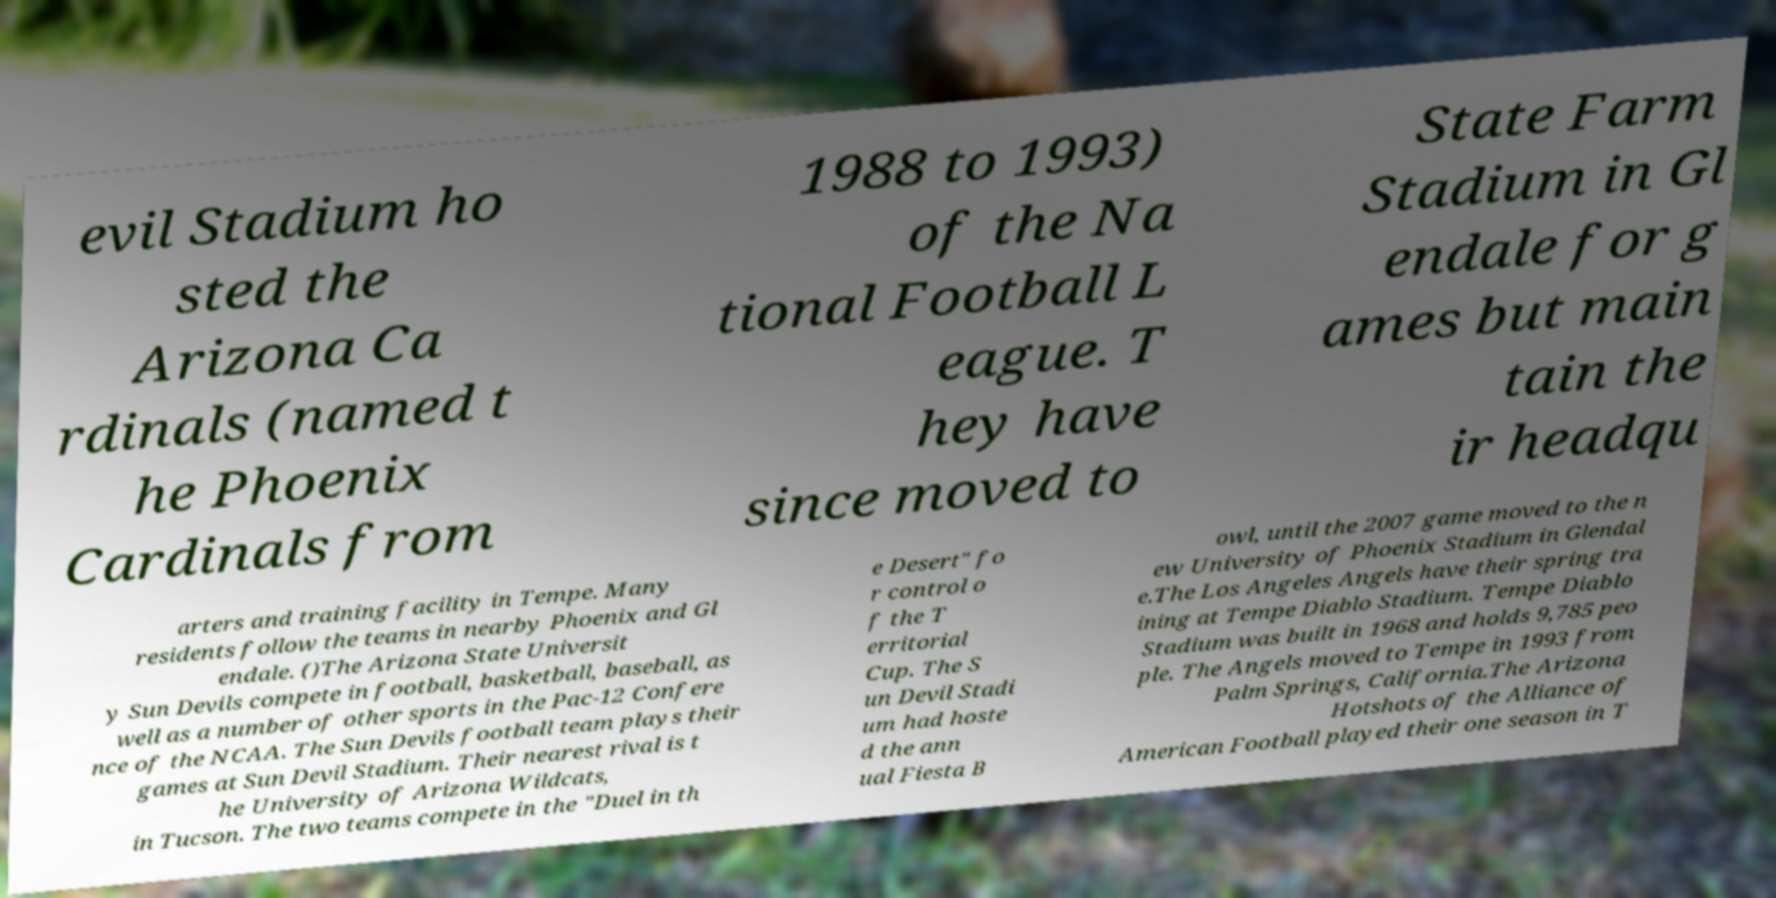For documentation purposes, I need the text within this image transcribed. Could you provide that? evil Stadium ho sted the Arizona Ca rdinals (named t he Phoenix Cardinals from 1988 to 1993) of the Na tional Football L eague. T hey have since moved to State Farm Stadium in Gl endale for g ames but main tain the ir headqu arters and training facility in Tempe. Many residents follow the teams in nearby Phoenix and Gl endale. ()The Arizona State Universit y Sun Devils compete in football, basketball, baseball, as well as a number of other sports in the Pac-12 Confere nce of the NCAA. The Sun Devils football team plays their games at Sun Devil Stadium. Their nearest rival is t he University of Arizona Wildcats, in Tucson. The two teams compete in the "Duel in th e Desert" fo r control o f the T erritorial Cup. The S un Devil Stadi um had hoste d the ann ual Fiesta B owl, until the 2007 game moved to the n ew University of Phoenix Stadium in Glendal e.The Los Angeles Angels have their spring tra ining at Tempe Diablo Stadium. Tempe Diablo Stadium was built in 1968 and holds 9,785 peo ple. The Angels moved to Tempe in 1993 from Palm Springs, California.The Arizona Hotshots of the Alliance of American Football played their one season in T 